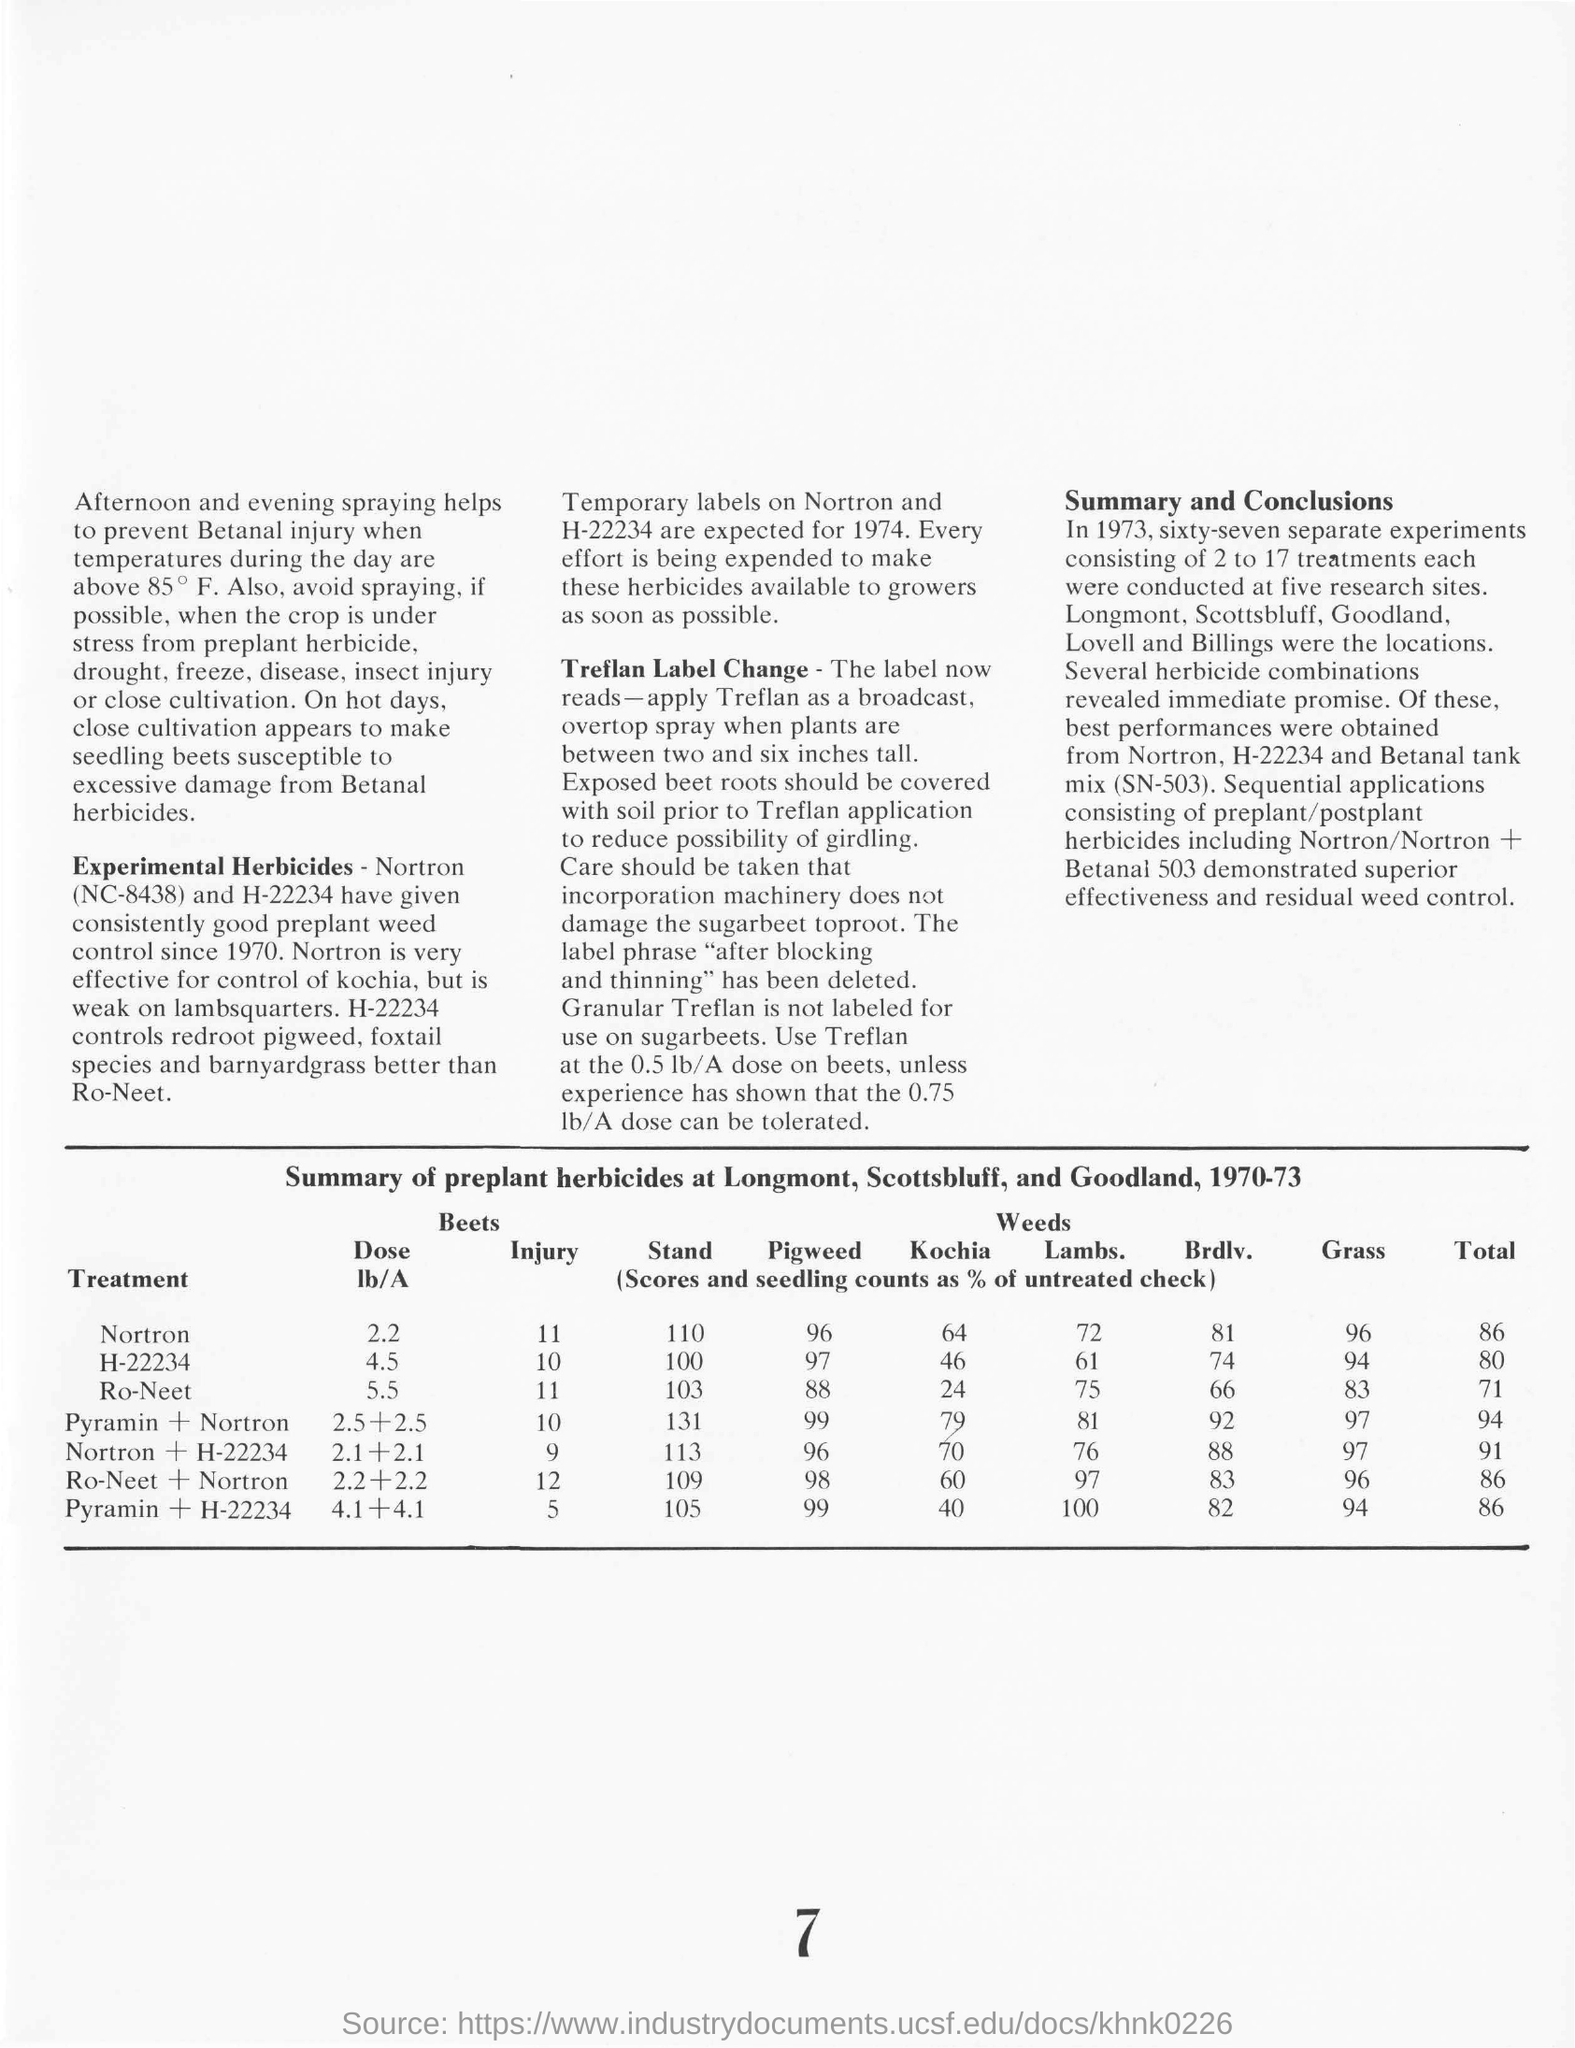What is the total for Nortron?
Keep it short and to the point. 86. What is the injury number given for ro-neet ?
Ensure brevity in your answer.  11. What is the label phrase deleted?
Provide a short and direct response. "after blocking and thinning". 